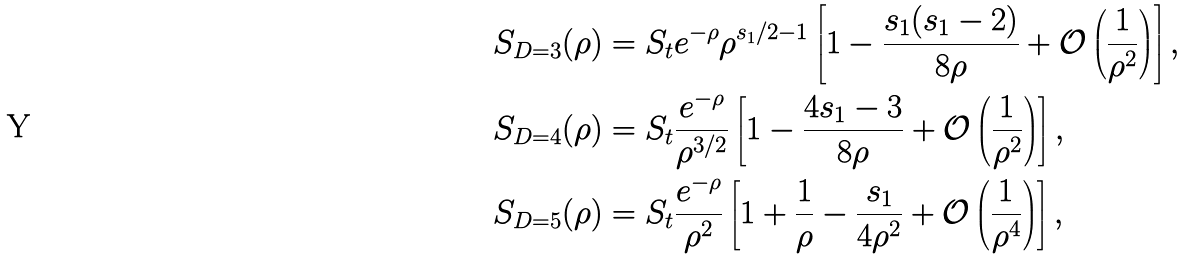Convert formula to latex. <formula><loc_0><loc_0><loc_500><loc_500>S _ { D = 3 } ( \rho ) & = S _ { t } e ^ { - \rho } \rho ^ { s _ { 1 } / 2 - 1 } \left [ 1 - \frac { s _ { 1 } ( s _ { 1 } - 2 ) } { 8 \rho } + \mathcal { O } \left ( \frac { 1 } { \rho ^ { 2 } } \right ) \right ] , \\ S _ { D = 4 } ( \rho ) & = S _ { t } \frac { e ^ { - \rho } } { \rho ^ { 3 / 2 } } \left [ 1 - \frac { 4 s _ { 1 } - 3 } { 8 \rho } + \mathcal { O } \left ( \frac { 1 } { \rho ^ { 2 } } \right ) \right ] , \\ S _ { D = 5 } ( \rho ) & = S _ { t } \frac { e ^ { - \rho } } { \rho ^ { 2 } } \left [ 1 + \frac { 1 } { \rho } - \frac { s _ { 1 } } { 4 \rho ^ { 2 } } + \mathcal { O } \left ( \frac { 1 } { \rho ^ { 4 } } \right ) \right ] ,</formula> 